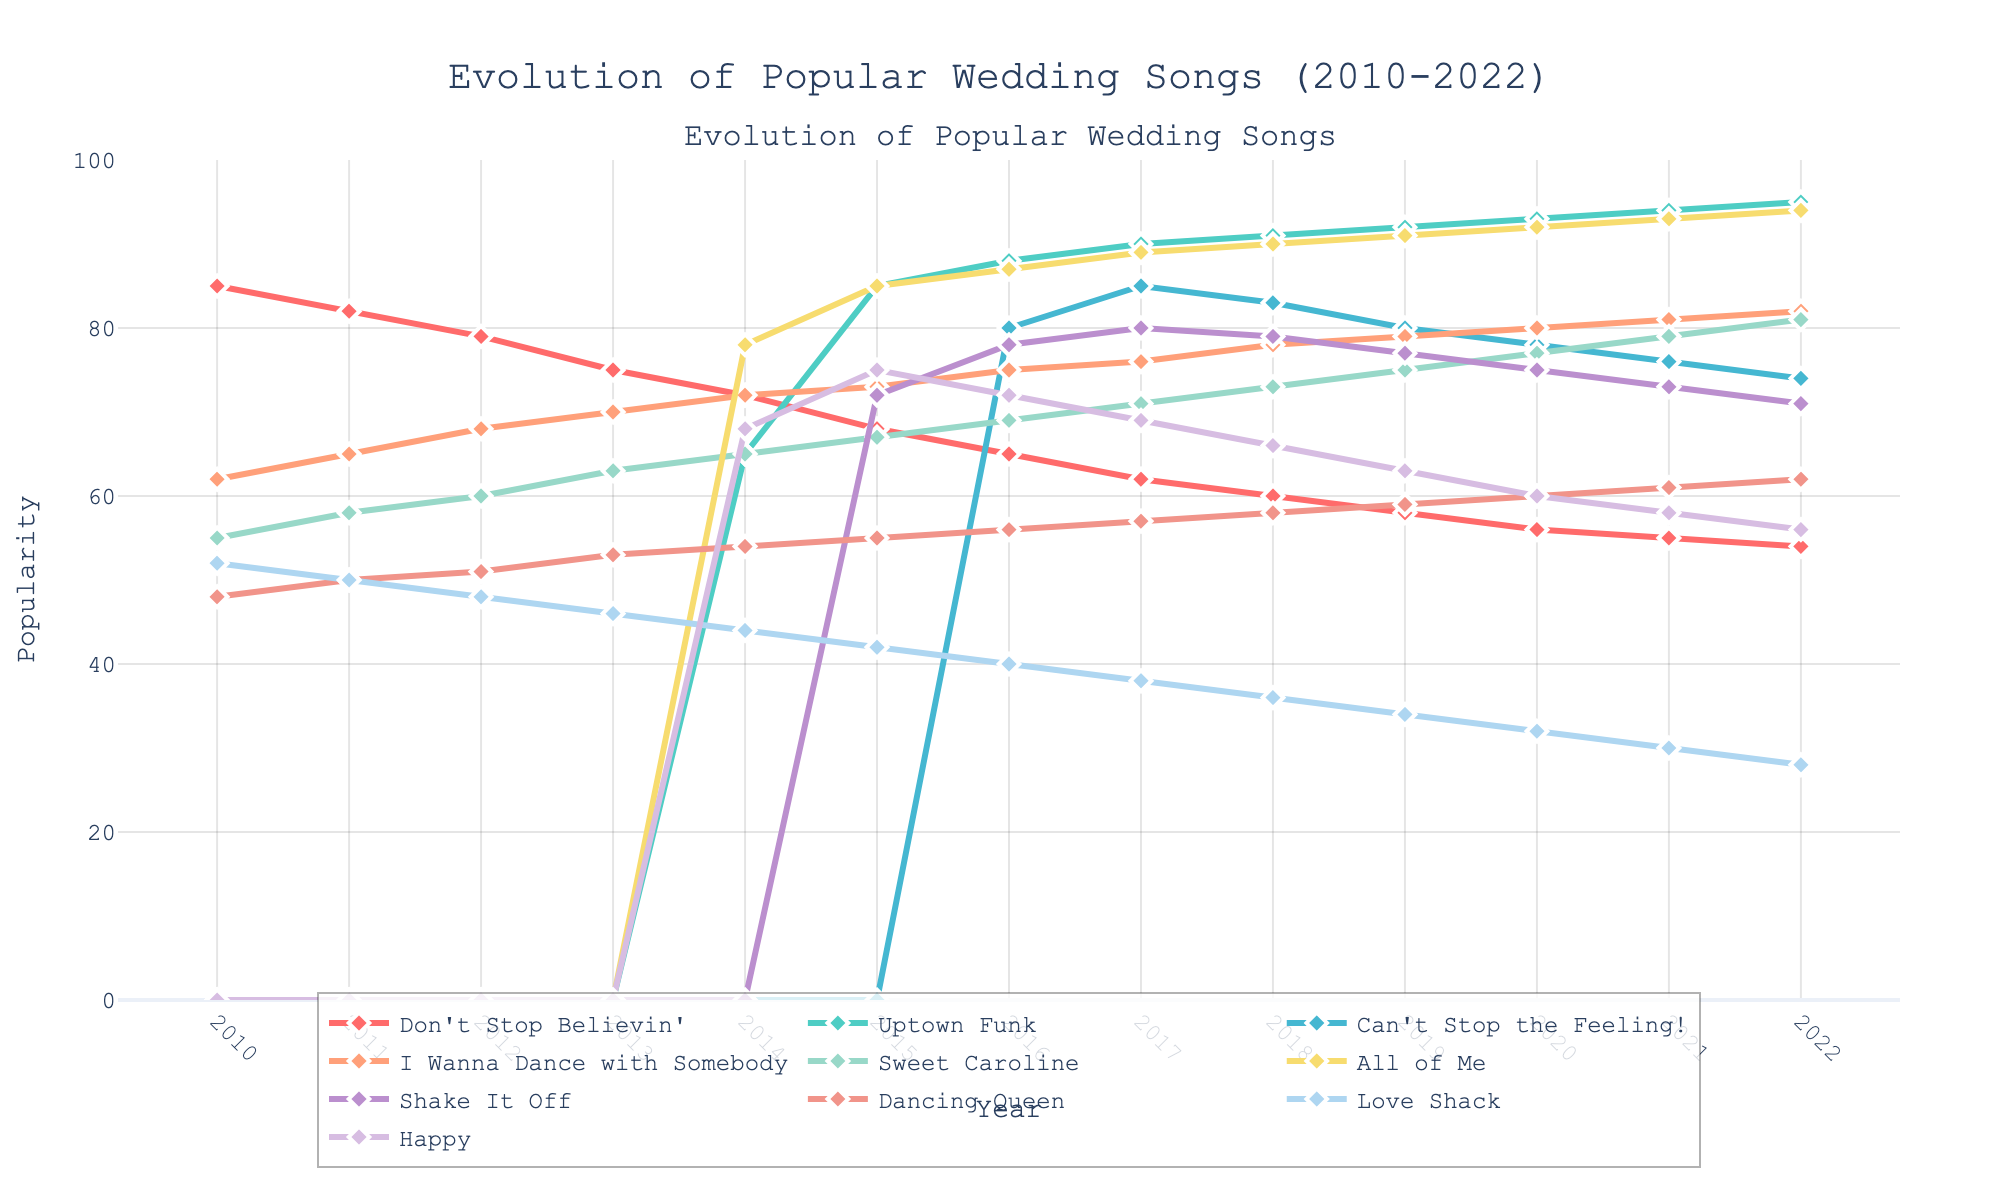What's the most popular wedding song in 2022? The graph shows the popularity of different wedding songs by year. In 2022, the light blue line representing "Uptown Funk" reaches the highest value on the y-axis.
Answer: Uptown Funk Which song saw a significant rise in popularity between 2011 and 2014? Observing the trends, only "Uptown Funk" shows a dramatic increase, starting from 0 in 2011 to a notable rise in 2014.
Answer: Uptown Funk What was the popularity trend of "Don't Stop Believin'" from 2010 to 2022? The pink line representing "Don't Stop Believin'" starts at 85 in 2010 and steadily decreases each year to 54 by 2022.
Answer: Decreasing By how much did the popularity of "Happy" increase from 2010 to its peak? "Happy" starts at 0 in 2010 and peaks at 75 in 2015. The increase is 75 - 0.
Answer: 75 Which two songs had almost equal popularity around 2020? By looking closely, "Shake It Off" (75) and "Don't Stop Believin'" (56) in 2020 have similar popularity levels that form nearly overlapping lines.
Answer: Shake It Off and Don't Stop Believin' Which song showed a sudden drop in popularity right after being introduced? "Can't Stop the Feeling!" shows a steep rise from 2014 then exhibits a decline starting from 2018.
Answer: Can't Stop the Feeling! During which year did "All of Me" reach its peak popularity? Following the yellow line for "All of Me," it reached its peak at around 94 in 2022, showing growth from earlier years.
Answer: 2022 What noticeable trend can be seen in the popularity of "Sweet Caroline"? The blue-green line for "Sweet Caroline" steadily rises from 2010 to 2022 without any dramatic changes in its trend.
Answer: Increasing Compare the popularity of "Dancing Queen" and "Love Shack" in 2014. Which was more popular? At 2014, "Dancing Queen" (red line) is slightly higher than "Love Shack" (green line). Checking the y-axis values, "Dancing Queen" has a higher value.
Answer: Dancing Queen How did the popularity of "I Wanna Dance with Somebody" change from 2010 to 2017? The purple line representing "I Wanna Dance with Somebody" shows a consistent rise in popularity from 62 in 2010 to 76 in 2017.
Answer: Increasing 